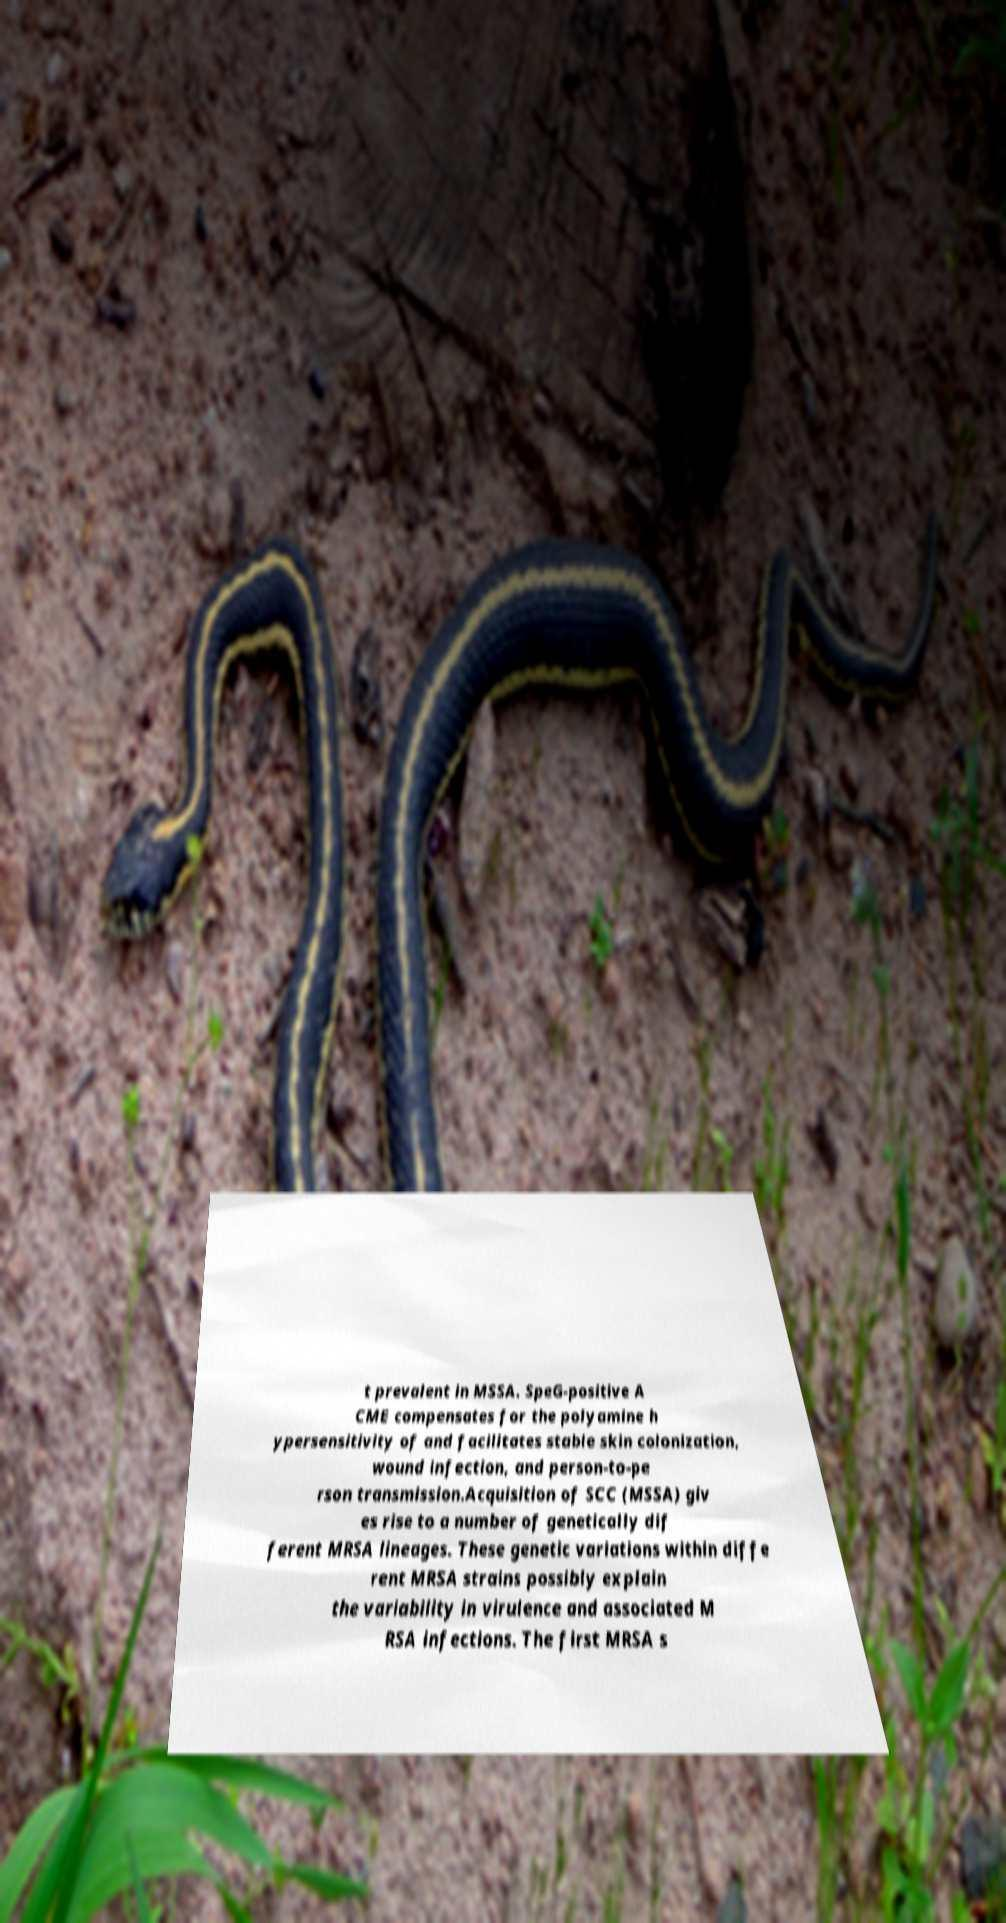Can you accurately transcribe the text from the provided image for me? t prevalent in MSSA. SpeG-positive A CME compensates for the polyamine h ypersensitivity of and facilitates stable skin colonization, wound infection, and person-to-pe rson transmission.Acquisition of SCC (MSSA) giv es rise to a number of genetically dif ferent MRSA lineages. These genetic variations within diffe rent MRSA strains possibly explain the variability in virulence and associated M RSA infections. The first MRSA s 